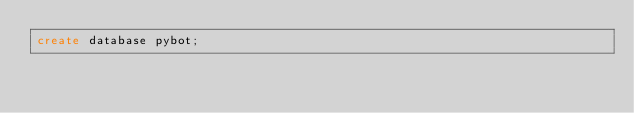Convert code to text. <code><loc_0><loc_0><loc_500><loc_500><_SQL_>create database pybot;</code> 